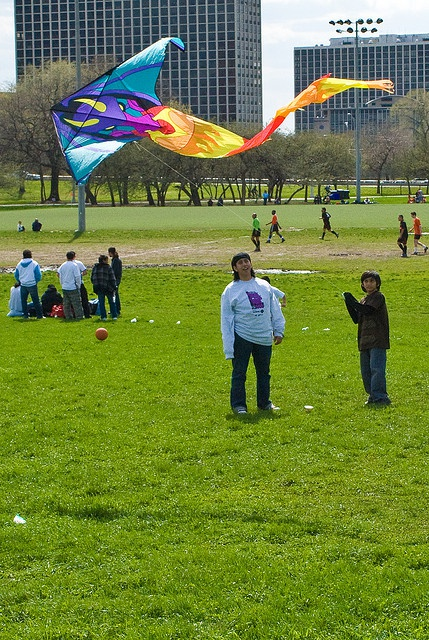Describe the objects in this image and their specific colors. I can see kite in lavender, teal, orange, ivory, and khaki tones, people in lavender, black, gray, and darkgray tones, people in lavender, black, olive, and darkgreen tones, people in lavender, black, darkblue, darkgreen, and olive tones, and people in lavender, black, darkgray, gray, and purple tones in this image. 